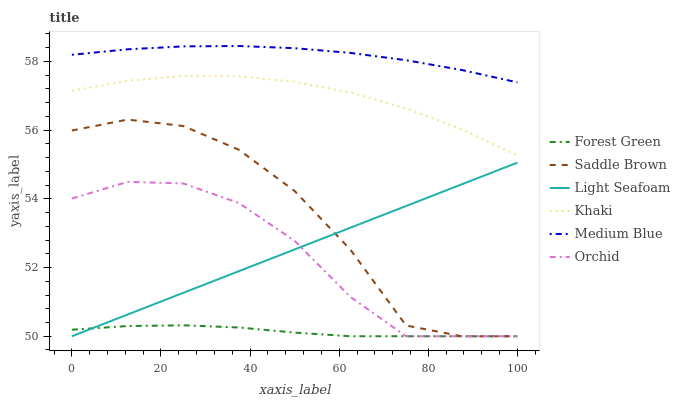Does Medium Blue have the minimum area under the curve?
Answer yes or no. No. Does Forest Green have the maximum area under the curve?
Answer yes or no. No. Is Medium Blue the smoothest?
Answer yes or no. No. Is Medium Blue the roughest?
Answer yes or no. No. Does Medium Blue have the lowest value?
Answer yes or no. No. Does Forest Green have the highest value?
Answer yes or no. No. Is Saddle Brown less than Medium Blue?
Answer yes or no. Yes. Is Medium Blue greater than Orchid?
Answer yes or no. Yes. Does Saddle Brown intersect Medium Blue?
Answer yes or no. No. 